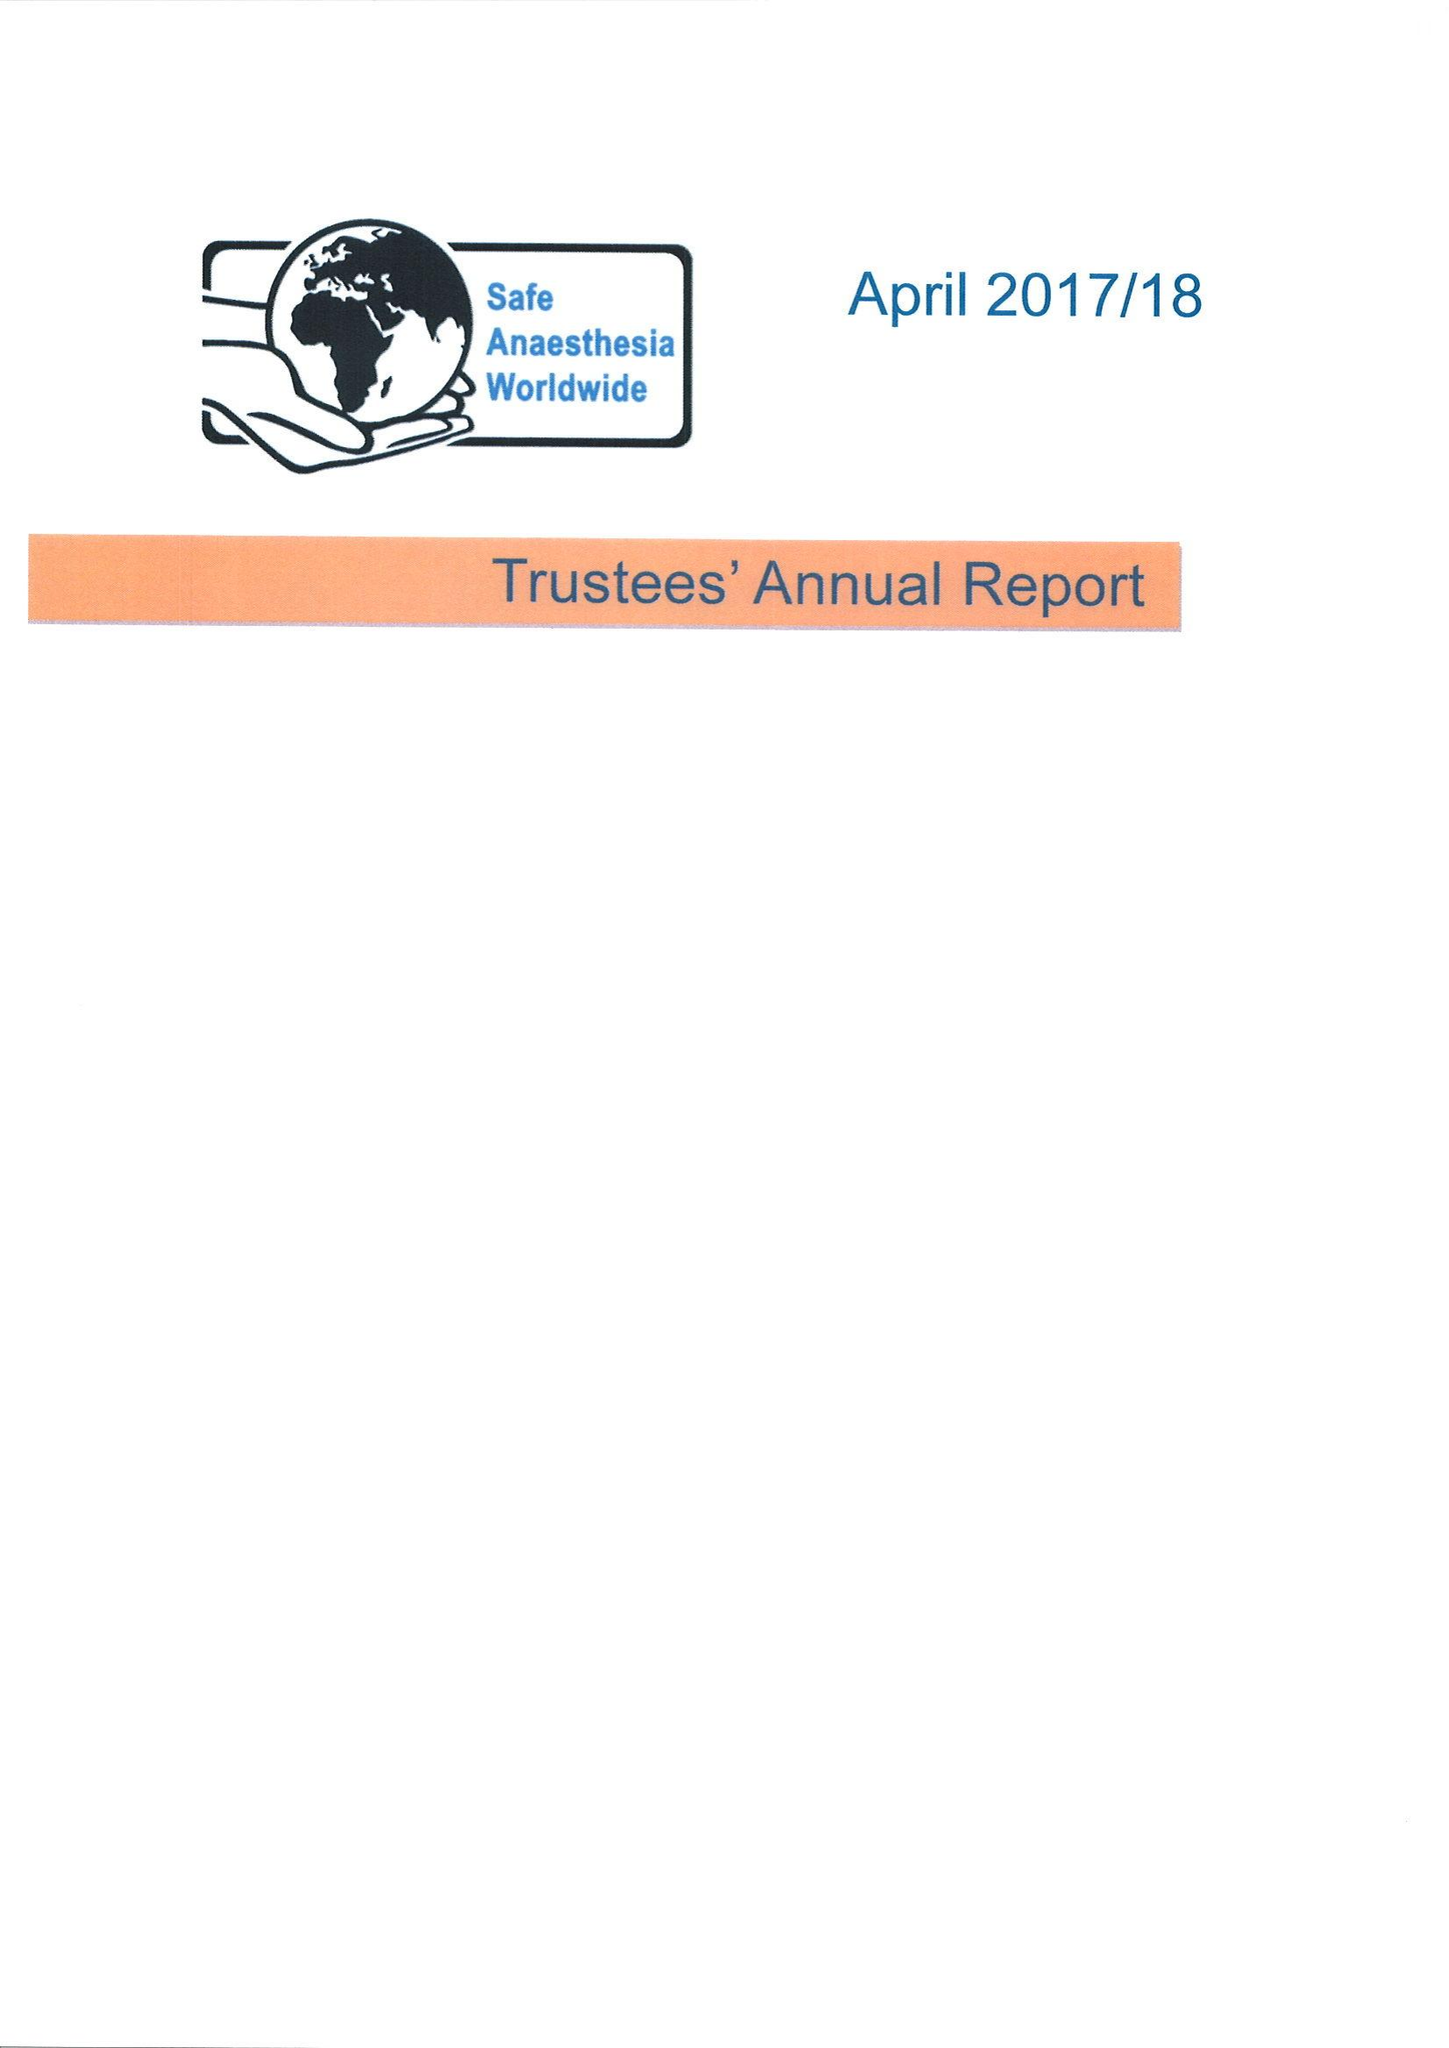What is the value for the income_annually_in_british_pounds?
Answer the question using a single word or phrase. 59891.00 